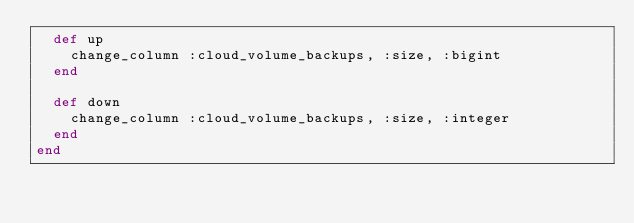Convert code to text. <code><loc_0><loc_0><loc_500><loc_500><_Ruby_>  def up
    change_column :cloud_volume_backups, :size, :bigint
  end

  def down
    change_column :cloud_volume_backups, :size, :integer
  end
end
</code> 